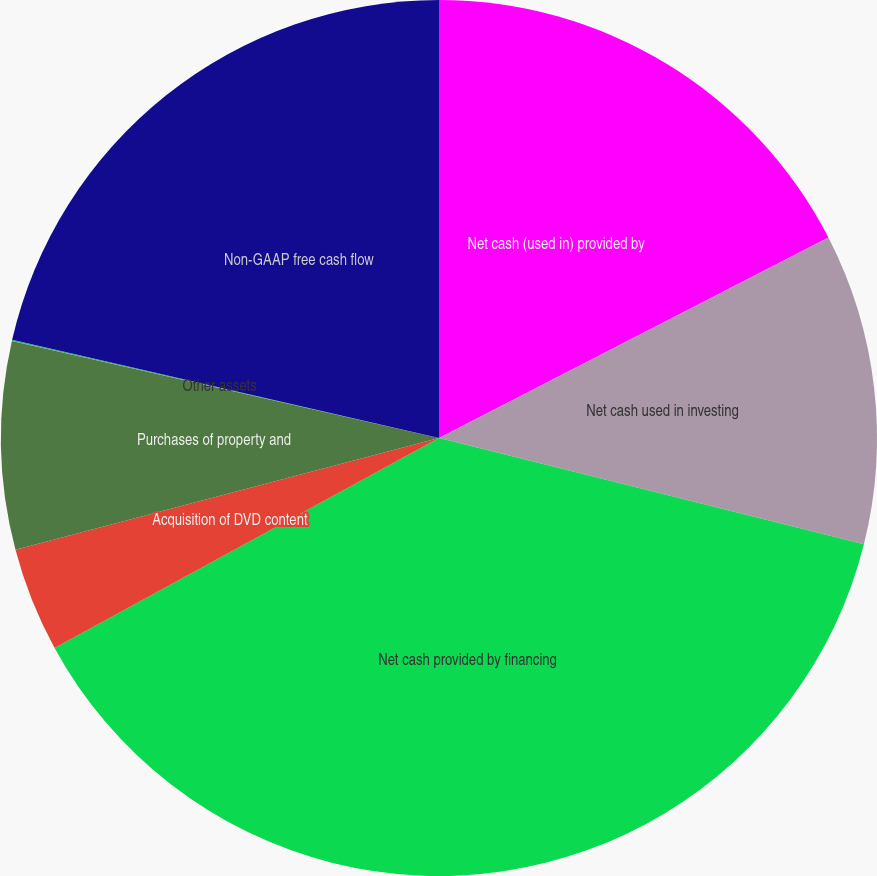Convert chart to OTSL. <chart><loc_0><loc_0><loc_500><loc_500><pie_chart><fcel>Net cash (used in) provided by<fcel>Net cash used in investing<fcel>Net cash provided by financing<fcel>Acquisition of DVD content<fcel>Purchases of property and<fcel>Other assets<fcel>Non-GAAP free cash flow<nl><fcel>17.43%<fcel>11.47%<fcel>38.14%<fcel>3.85%<fcel>7.66%<fcel>0.04%<fcel>21.4%<nl></chart> 